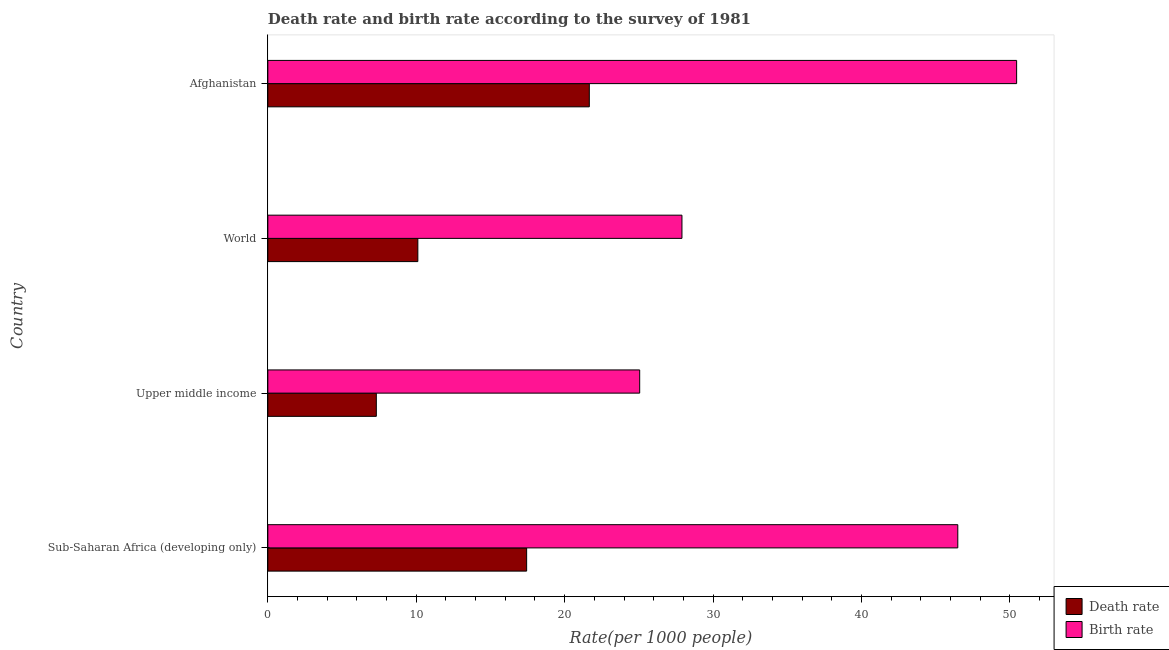How many different coloured bars are there?
Give a very brief answer. 2. Are the number of bars per tick equal to the number of legend labels?
Offer a very short reply. Yes. Are the number of bars on each tick of the Y-axis equal?
Your answer should be very brief. Yes. How many bars are there on the 1st tick from the bottom?
Offer a very short reply. 2. What is the label of the 1st group of bars from the top?
Give a very brief answer. Afghanistan. In how many cases, is the number of bars for a given country not equal to the number of legend labels?
Make the answer very short. 0. What is the birth rate in Afghanistan?
Make the answer very short. 50.46. Across all countries, what is the maximum birth rate?
Ensure brevity in your answer.  50.46. Across all countries, what is the minimum birth rate?
Offer a very short reply. 25.06. In which country was the birth rate maximum?
Make the answer very short. Afghanistan. In which country was the birth rate minimum?
Offer a terse response. Upper middle income. What is the total birth rate in the graph?
Offer a terse response. 149.91. What is the difference between the birth rate in Sub-Saharan Africa (developing only) and that in World?
Offer a terse response. 18.59. What is the difference between the birth rate in World and the death rate in Upper middle income?
Provide a short and direct response. 20.6. What is the average birth rate per country?
Your answer should be compact. 37.48. What is the difference between the birth rate and death rate in Upper middle income?
Your answer should be very brief. 17.75. In how many countries, is the death rate greater than 4 ?
Your response must be concise. 4. What is the ratio of the death rate in Sub-Saharan Africa (developing only) to that in World?
Make the answer very short. 1.73. What is the difference between the highest and the second highest birth rate?
Your answer should be compact. 3.96. What is the difference between the highest and the lowest birth rate?
Your response must be concise. 25.4. Is the sum of the death rate in Upper middle income and World greater than the maximum birth rate across all countries?
Provide a short and direct response. No. What does the 1st bar from the top in Afghanistan represents?
Provide a succinct answer. Birth rate. What does the 2nd bar from the bottom in Upper middle income represents?
Your answer should be compact. Birth rate. How many bars are there?
Keep it short and to the point. 8. Are all the bars in the graph horizontal?
Offer a very short reply. Yes. How many countries are there in the graph?
Keep it short and to the point. 4. Are the values on the major ticks of X-axis written in scientific E-notation?
Keep it short and to the point. No. Where does the legend appear in the graph?
Provide a succinct answer. Bottom right. What is the title of the graph?
Your response must be concise. Death rate and birth rate according to the survey of 1981. Does "Not attending school" appear as one of the legend labels in the graph?
Provide a succinct answer. No. What is the label or title of the X-axis?
Give a very brief answer. Rate(per 1000 people). What is the label or title of the Y-axis?
Your answer should be compact. Country. What is the Rate(per 1000 people) in Death rate in Sub-Saharan Africa (developing only)?
Make the answer very short. 17.44. What is the Rate(per 1000 people) in Birth rate in Sub-Saharan Africa (developing only)?
Your response must be concise. 46.49. What is the Rate(per 1000 people) of Death rate in Upper middle income?
Give a very brief answer. 7.31. What is the Rate(per 1000 people) in Birth rate in Upper middle income?
Your answer should be very brief. 25.06. What is the Rate(per 1000 people) of Death rate in World?
Provide a succinct answer. 10.11. What is the Rate(per 1000 people) of Birth rate in World?
Give a very brief answer. 27.91. What is the Rate(per 1000 people) in Death rate in Afghanistan?
Give a very brief answer. 21.66. What is the Rate(per 1000 people) in Birth rate in Afghanistan?
Provide a short and direct response. 50.46. Across all countries, what is the maximum Rate(per 1000 people) of Death rate?
Ensure brevity in your answer.  21.66. Across all countries, what is the maximum Rate(per 1000 people) in Birth rate?
Provide a succinct answer. 50.46. Across all countries, what is the minimum Rate(per 1000 people) in Death rate?
Provide a short and direct response. 7.31. Across all countries, what is the minimum Rate(per 1000 people) of Birth rate?
Ensure brevity in your answer.  25.06. What is the total Rate(per 1000 people) in Death rate in the graph?
Your response must be concise. 56.52. What is the total Rate(per 1000 people) in Birth rate in the graph?
Offer a very short reply. 149.91. What is the difference between the Rate(per 1000 people) in Death rate in Sub-Saharan Africa (developing only) and that in Upper middle income?
Provide a short and direct response. 10.13. What is the difference between the Rate(per 1000 people) in Birth rate in Sub-Saharan Africa (developing only) and that in Upper middle income?
Make the answer very short. 21.44. What is the difference between the Rate(per 1000 people) of Death rate in Sub-Saharan Africa (developing only) and that in World?
Provide a succinct answer. 7.33. What is the difference between the Rate(per 1000 people) in Birth rate in Sub-Saharan Africa (developing only) and that in World?
Give a very brief answer. 18.59. What is the difference between the Rate(per 1000 people) in Death rate in Sub-Saharan Africa (developing only) and that in Afghanistan?
Your answer should be very brief. -4.22. What is the difference between the Rate(per 1000 people) in Birth rate in Sub-Saharan Africa (developing only) and that in Afghanistan?
Keep it short and to the point. -3.96. What is the difference between the Rate(per 1000 people) in Death rate in Upper middle income and that in World?
Your response must be concise. -2.8. What is the difference between the Rate(per 1000 people) of Birth rate in Upper middle income and that in World?
Your answer should be compact. -2.85. What is the difference between the Rate(per 1000 people) in Death rate in Upper middle income and that in Afghanistan?
Provide a short and direct response. -14.35. What is the difference between the Rate(per 1000 people) in Birth rate in Upper middle income and that in Afghanistan?
Make the answer very short. -25.4. What is the difference between the Rate(per 1000 people) in Death rate in World and that in Afghanistan?
Offer a terse response. -11.55. What is the difference between the Rate(per 1000 people) of Birth rate in World and that in Afghanistan?
Your answer should be very brief. -22.55. What is the difference between the Rate(per 1000 people) of Death rate in Sub-Saharan Africa (developing only) and the Rate(per 1000 people) of Birth rate in Upper middle income?
Ensure brevity in your answer.  -7.62. What is the difference between the Rate(per 1000 people) of Death rate in Sub-Saharan Africa (developing only) and the Rate(per 1000 people) of Birth rate in World?
Your response must be concise. -10.47. What is the difference between the Rate(per 1000 people) of Death rate in Sub-Saharan Africa (developing only) and the Rate(per 1000 people) of Birth rate in Afghanistan?
Keep it short and to the point. -33.02. What is the difference between the Rate(per 1000 people) in Death rate in Upper middle income and the Rate(per 1000 people) in Birth rate in World?
Provide a short and direct response. -20.6. What is the difference between the Rate(per 1000 people) in Death rate in Upper middle income and the Rate(per 1000 people) in Birth rate in Afghanistan?
Your answer should be very brief. -43.15. What is the difference between the Rate(per 1000 people) of Death rate in World and the Rate(per 1000 people) of Birth rate in Afghanistan?
Provide a short and direct response. -40.35. What is the average Rate(per 1000 people) in Death rate per country?
Your answer should be very brief. 14.13. What is the average Rate(per 1000 people) in Birth rate per country?
Give a very brief answer. 37.48. What is the difference between the Rate(per 1000 people) of Death rate and Rate(per 1000 people) of Birth rate in Sub-Saharan Africa (developing only)?
Your answer should be compact. -29.05. What is the difference between the Rate(per 1000 people) in Death rate and Rate(per 1000 people) in Birth rate in Upper middle income?
Make the answer very short. -17.75. What is the difference between the Rate(per 1000 people) in Death rate and Rate(per 1000 people) in Birth rate in World?
Ensure brevity in your answer.  -17.8. What is the difference between the Rate(per 1000 people) of Death rate and Rate(per 1000 people) of Birth rate in Afghanistan?
Your answer should be very brief. -28.8. What is the ratio of the Rate(per 1000 people) in Death rate in Sub-Saharan Africa (developing only) to that in Upper middle income?
Provide a short and direct response. 2.39. What is the ratio of the Rate(per 1000 people) of Birth rate in Sub-Saharan Africa (developing only) to that in Upper middle income?
Provide a short and direct response. 1.86. What is the ratio of the Rate(per 1000 people) of Death rate in Sub-Saharan Africa (developing only) to that in World?
Ensure brevity in your answer.  1.73. What is the ratio of the Rate(per 1000 people) in Birth rate in Sub-Saharan Africa (developing only) to that in World?
Keep it short and to the point. 1.67. What is the ratio of the Rate(per 1000 people) in Death rate in Sub-Saharan Africa (developing only) to that in Afghanistan?
Your response must be concise. 0.81. What is the ratio of the Rate(per 1000 people) of Birth rate in Sub-Saharan Africa (developing only) to that in Afghanistan?
Offer a terse response. 0.92. What is the ratio of the Rate(per 1000 people) of Death rate in Upper middle income to that in World?
Your answer should be compact. 0.72. What is the ratio of the Rate(per 1000 people) in Birth rate in Upper middle income to that in World?
Give a very brief answer. 0.9. What is the ratio of the Rate(per 1000 people) in Death rate in Upper middle income to that in Afghanistan?
Offer a terse response. 0.34. What is the ratio of the Rate(per 1000 people) of Birth rate in Upper middle income to that in Afghanistan?
Offer a terse response. 0.5. What is the ratio of the Rate(per 1000 people) in Death rate in World to that in Afghanistan?
Provide a short and direct response. 0.47. What is the ratio of the Rate(per 1000 people) in Birth rate in World to that in Afghanistan?
Ensure brevity in your answer.  0.55. What is the difference between the highest and the second highest Rate(per 1000 people) in Death rate?
Provide a succinct answer. 4.22. What is the difference between the highest and the second highest Rate(per 1000 people) in Birth rate?
Provide a succinct answer. 3.96. What is the difference between the highest and the lowest Rate(per 1000 people) of Death rate?
Your answer should be very brief. 14.35. What is the difference between the highest and the lowest Rate(per 1000 people) of Birth rate?
Your answer should be compact. 25.4. 